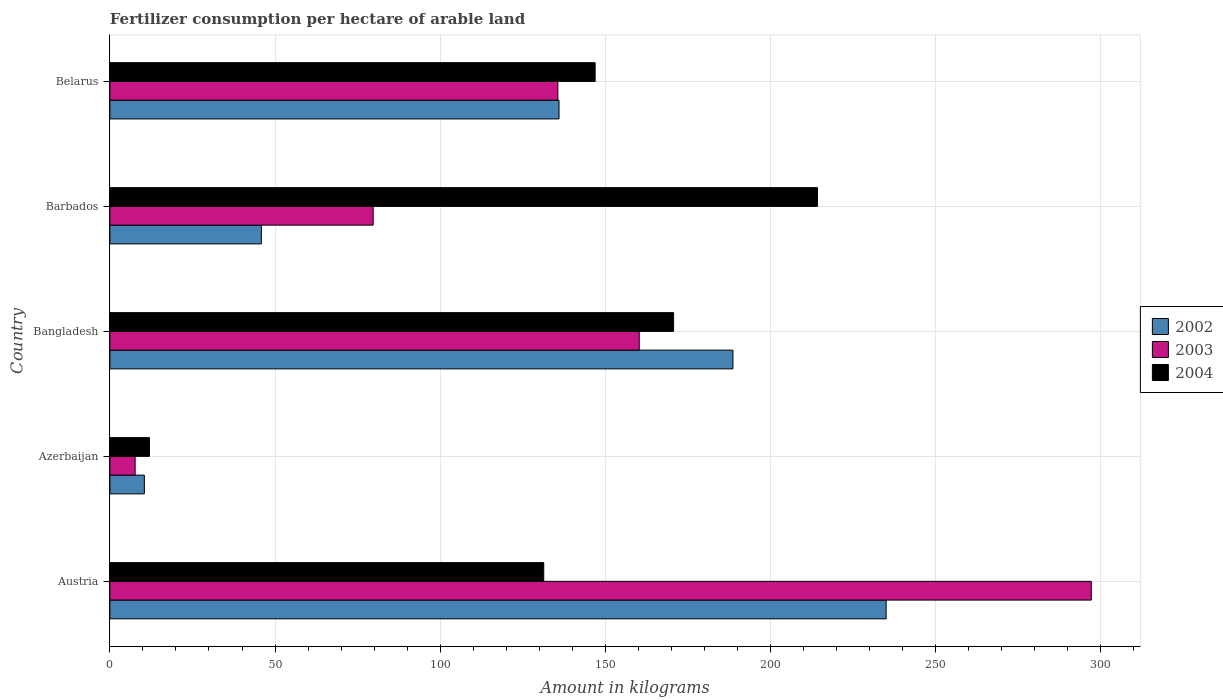How many different coloured bars are there?
Give a very brief answer. 3. Are the number of bars per tick equal to the number of legend labels?
Offer a very short reply. Yes. Are the number of bars on each tick of the Y-axis equal?
Provide a short and direct response. Yes. How many bars are there on the 3rd tick from the top?
Keep it short and to the point. 3. In how many cases, is the number of bars for a given country not equal to the number of legend labels?
Your answer should be very brief. 0. What is the amount of fertilizer consumption in 2002 in Austria?
Make the answer very short. 235.03. Across all countries, what is the maximum amount of fertilizer consumption in 2002?
Your response must be concise. 235.03. Across all countries, what is the minimum amount of fertilizer consumption in 2002?
Ensure brevity in your answer.  10.43. In which country was the amount of fertilizer consumption in 2004 maximum?
Offer a very short reply. Barbados. In which country was the amount of fertilizer consumption in 2002 minimum?
Your answer should be compact. Azerbaijan. What is the total amount of fertilizer consumption in 2003 in the graph?
Give a very brief answer. 680.39. What is the difference between the amount of fertilizer consumption in 2004 in Austria and that in Belarus?
Your response must be concise. -15.57. What is the difference between the amount of fertilizer consumption in 2003 in Barbados and the amount of fertilizer consumption in 2004 in Belarus?
Your answer should be compact. -67.2. What is the average amount of fertilizer consumption in 2003 per country?
Your response must be concise. 136.08. What is the difference between the amount of fertilizer consumption in 2003 and amount of fertilizer consumption in 2004 in Bangladesh?
Keep it short and to the point. -10.4. In how many countries, is the amount of fertilizer consumption in 2004 greater than 40 kg?
Make the answer very short. 4. What is the ratio of the amount of fertilizer consumption in 2002 in Azerbaijan to that in Belarus?
Your answer should be very brief. 0.08. Is the amount of fertilizer consumption in 2003 in Bangladesh less than that in Belarus?
Your answer should be compact. No. What is the difference between the highest and the second highest amount of fertilizer consumption in 2004?
Offer a very short reply. 43.56. What is the difference between the highest and the lowest amount of fertilizer consumption in 2004?
Ensure brevity in your answer.  202.26. In how many countries, is the amount of fertilizer consumption in 2003 greater than the average amount of fertilizer consumption in 2003 taken over all countries?
Provide a short and direct response. 2. Is the sum of the amount of fertilizer consumption in 2004 in Bangladesh and Barbados greater than the maximum amount of fertilizer consumption in 2003 across all countries?
Your answer should be compact. Yes. What does the 2nd bar from the top in Bangladesh represents?
Give a very brief answer. 2003. What does the 2nd bar from the bottom in Bangladesh represents?
Offer a very short reply. 2003. Is it the case that in every country, the sum of the amount of fertilizer consumption in 2002 and amount of fertilizer consumption in 2003 is greater than the amount of fertilizer consumption in 2004?
Your answer should be compact. No. What is the difference between two consecutive major ticks on the X-axis?
Give a very brief answer. 50. Are the values on the major ticks of X-axis written in scientific E-notation?
Provide a short and direct response. No. Does the graph contain grids?
Your answer should be very brief. Yes. Where does the legend appear in the graph?
Offer a terse response. Center right. How many legend labels are there?
Provide a short and direct response. 3. How are the legend labels stacked?
Give a very brief answer. Vertical. What is the title of the graph?
Provide a succinct answer. Fertilizer consumption per hectare of arable land. Does "1993" appear as one of the legend labels in the graph?
Your response must be concise. No. What is the label or title of the X-axis?
Keep it short and to the point. Amount in kilograms. What is the Amount in kilograms in 2002 in Austria?
Make the answer very short. 235.03. What is the Amount in kilograms of 2003 in Austria?
Provide a succinct answer. 297.14. What is the Amount in kilograms of 2004 in Austria?
Your answer should be very brief. 131.35. What is the Amount in kilograms in 2002 in Azerbaijan?
Provide a succinct answer. 10.43. What is the Amount in kilograms of 2003 in Azerbaijan?
Give a very brief answer. 7.64. What is the Amount in kilograms of 2004 in Azerbaijan?
Keep it short and to the point. 11.97. What is the Amount in kilograms of 2002 in Bangladesh?
Your response must be concise. 188.64. What is the Amount in kilograms in 2003 in Bangladesh?
Offer a terse response. 160.27. What is the Amount in kilograms in 2004 in Bangladesh?
Give a very brief answer. 170.67. What is the Amount in kilograms of 2002 in Barbados?
Your response must be concise. 45.86. What is the Amount in kilograms in 2003 in Barbados?
Provide a succinct answer. 79.71. What is the Amount in kilograms of 2004 in Barbados?
Your answer should be compact. 214.23. What is the Amount in kilograms of 2002 in Belarus?
Your answer should be compact. 135.99. What is the Amount in kilograms in 2003 in Belarus?
Your response must be concise. 135.63. What is the Amount in kilograms in 2004 in Belarus?
Offer a very short reply. 146.92. Across all countries, what is the maximum Amount in kilograms in 2002?
Your response must be concise. 235.03. Across all countries, what is the maximum Amount in kilograms in 2003?
Your answer should be compact. 297.14. Across all countries, what is the maximum Amount in kilograms of 2004?
Provide a succinct answer. 214.23. Across all countries, what is the minimum Amount in kilograms of 2002?
Provide a short and direct response. 10.43. Across all countries, what is the minimum Amount in kilograms of 2003?
Your answer should be compact. 7.64. Across all countries, what is the minimum Amount in kilograms in 2004?
Give a very brief answer. 11.97. What is the total Amount in kilograms of 2002 in the graph?
Offer a terse response. 615.94. What is the total Amount in kilograms of 2003 in the graph?
Your response must be concise. 680.39. What is the total Amount in kilograms of 2004 in the graph?
Provide a short and direct response. 675.15. What is the difference between the Amount in kilograms of 2002 in Austria and that in Azerbaijan?
Ensure brevity in your answer.  224.59. What is the difference between the Amount in kilograms in 2003 in Austria and that in Azerbaijan?
Give a very brief answer. 289.5. What is the difference between the Amount in kilograms in 2004 in Austria and that in Azerbaijan?
Provide a succinct answer. 119.38. What is the difference between the Amount in kilograms of 2002 in Austria and that in Bangladesh?
Make the answer very short. 46.39. What is the difference between the Amount in kilograms in 2003 in Austria and that in Bangladesh?
Make the answer very short. 136.87. What is the difference between the Amount in kilograms of 2004 in Austria and that in Bangladesh?
Your answer should be compact. -39.32. What is the difference between the Amount in kilograms of 2002 in Austria and that in Barbados?
Provide a short and direct response. 189.17. What is the difference between the Amount in kilograms in 2003 in Austria and that in Barbados?
Your answer should be compact. 217.42. What is the difference between the Amount in kilograms in 2004 in Austria and that in Barbados?
Your answer should be very brief. -82.88. What is the difference between the Amount in kilograms in 2002 in Austria and that in Belarus?
Your answer should be compact. 99.04. What is the difference between the Amount in kilograms in 2003 in Austria and that in Belarus?
Your response must be concise. 161.51. What is the difference between the Amount in kilograms of 2004 in Austria and that in Belarus?
Provide a succinct answer. -15.57. What is the difference between the Amount in kilograms of 2002 in Azerbaijan and that in Bangladesh?
Your response must be concise. -178.21. What is the difference between the Amount in kilograms of 2003 in Azerbaijan and that in Bangladesh?
Your response must be concise. -152.62. What is the difference between the Amount in kilograms in 2004 in Azerbaijan and that in Bangladesh?
Your response must be concise. -158.7. What is the difference between the Amount in kilograms in 2002 in Azerbaijan and that in Barbados?
Your response must be concise. -35.42. What is the difference between the Amount in kilograms in 2003 in Azerbaijan and that in Barbados?
Keep it short and to the point. -72.07. What is the difference between the Amount in kilograms in 2004 in Azerbaijan and that in Barbados?
Your answer should be compact. -202.26. What is the difference between the Amount in kilograms in 2002 in Azerbaijan and that in Belarus?
Your answer should be very brief. -125.55. What is the difference between the Amount in kilograms of 2003 in Azerbaijan and that in Belarus?
Your answer should be very brief. -127.98. What is the difference between the Amount in kilograms in 2004 in Azerbaijan and that in Belarus?
Offer a very short reply. -134.94. What is the difference between the Amount in kilograms of 2002 in Bangladesh and that in Barbados?
Offer a terse response. 142.78. What is the difference between the Amount in kilograms in 2003 in Bangladesh and that in Barbados?
Offer a terse response. 80.55. What is the difference between the Amount in kilograms in 2004 in Bangladesh and that in Barbados?
Give a very brief answer. -43.56. What is the difference between the Amount in kilograms in 2002 in Bangladesh and that in Belarus?
Your answer should be very brief. 52.65. What is the difference between the Amount in kilograms of 2003 in Bangladesh and that in Belarus?
Your response must be concise. 24.64. What is the difference between the Amount in kilograms in 2004 in Bangladesh and that in Belarus?
Your answer should be very brief. 23.75. What is the difference between the Amount in kilograms in 2002 in Barbados and that in Belarus?
Provide a succinct answer. -90.13. What is the difference between the Amount in kilograms in 2003 in Barbados and that in Belarus?
Give a very brief answer. -55.91. What is the difference between the Amount in kilograms of 2004 in Barbados and that in Belarus?
Provide a short and direct response. 67.31. What is the difference between the Amount in kilograms in 2002 in Austria and the Amount in kilograms in 2003 in Azerbaijan?
Your answer should be compact. 227.38. What is the difference between the Amount in kilograms of 2002 in Austria and the Amount in kilograms of 2004 in Azerbaijan?
Your response must be concise. 223.05. What is the difference between the Amount in kilograms of 2003 in Austria and the Amount in kilograms of 2004 in Azerbaijan?
Offer a very short reply. 285.16. What is the difference between the Amount in kilograms in 2002 in Austria and the Amount in kilograms in 2003 in Bangladesh?
Keep it short and to the point. 74.76. What is the difference between the Amount in kilograms in 2002 in Austria and the Amount in kilograms in 2004 in Bangladesh?
Your response must be concise. 64.35. What is the difference between the Amount in kilograms in 2003 in Austria and the Amount in kilograms in 2004 in Bangladesh?
Provide a succinct answer. 126.47. What is the difference between the Amount in kilograms in 2002 in Austria and the Amount in kilograms in 2003 in Barbados?
Your answer should be compact. 155.31. What is the difference between the Amount in kilograms of 2002 in Austria and the Amount in kilograms of 2004 in Barbados?
Your answer should be compact. 20.79. What is the difference between the Amount in kilograms of 2003 in Austria and the Amount in kilograms of 2004 in Barbados?
Ensure brevity in your answer.  82.91. What is the difference between the Amount in kilograms of 2002 in Austria and the Amount in kilograms of 2003 in Belarus?
Provide a succinct answer. 99.4. What is the difference between the Amount in kilograms in 2002 in Austria and the Amount in kilograms in 2004 in Belarus?
Provide a short and direct response. 88.11. What is the difference between the Amount in kilograms in 2003 in Austria and the Amount in kilograms in 2004 in Belarus?
Provide a short and direct response. 150.22. What is the difference between the Amount in kilograms of 2002 in Azerbaijan and the Amount in kilograms of 2003 in Bangladesh?
Give a very brief answer. -149.83. What is the difference between the Amount in kilograms in 2002 in Azerbaijan and the Amount in kilograms in 2004 in Bangladesh?
Ensure brevity in your answer.  -160.24. What is the difference between the Amount in kilograms in 2003 in Azerbaijan and the Amount in kilograms in 2004 in Bangladesh?
Keep it short and to the point. -163.03. What is the difference between the Amount in kilograms of 2002 in Azerbaijan and the Amount in kilograms of 2003 in Barbados?
Provide a succinct answer. -69.28. What is the difference between the Amount in kilograms in 2002 in Azerbaijan and the Amount in kilograms in 2004 in Barbados?
Your answer should be compact. -203.8. What is the difference between the Amount in kilograms in 2003 in Azerbaijan and the Amount in kilograms in 2004 in Barbados?
Ensure brevity in your answer.  -206.59. What is the difference between the Amount in kilograms in 2002 in Azerbaijan and the Amount in kilograms in 2003 in Belarus?
Provide a succinct answer. -125.19. What is the difference between the Amount in kilograms of 2002 in Azerbaijan and the Amount in kilograms of 2004 in Belarus?
Ensure brevity in your answer.  -136.48. What is the difference between the Amount in kilograms of 2003 in Azerbaijan and the Amount in kilograms of 2004 in Belarus?
Offer a very short reply. -139.28. What is the difference between the Amount in kilograms of 2002 in Bangladesh and the Amount in kilograms of 2003 in Barbados?
Make the answer very short. 108.92. What is the difference between the Amount in kilograms of 2002 in Bangladesh and the Amount in kilograms of 2004 in Barbados?
Keep it short and to the point. -25.59. What is the difference between the Amount in kilograms of 2003 in Bangladesh and the Amount in kilograms of 2004 in Barbados?
Provide a succinct answer. -53.96. What is the difference between the Amount in kilograms in 2002 in Bangladesh and the Amount in kilograms in 2003 in Belarus?
Provide a succinct answer. 53.01. What is the difference between the Amount in kilograms in 2002 in Bangladesh and the Amount in kilograms in 2004 in Belarus?
Offer a terse response. 41.72. What is the difference between the Amount in kilograms of 2003 in Bangladesh and the Amount in kilograms of 2004 in Belarus?
Keep it short and to the point. 13.35. What is the difference between the Amount in kilograms of 2002 in Barbados and the Amount in kilograms of 2003 in Belarus?
Your answer should be compact. -89.77. What is the difference between the Amount in kilograms in 2002 in Barbados and the Amount in kilograms in 2004 in Belarus?
Give a very brief answer. -101.06. What is the difference between the Amount in kilograms in 2003 in Barbados and the Amount in kilograms in 2004 in Belarus?
Ensure brevity in your answer.  -67.2. What is the average Amount in kilograms in 2002 per country?
Provide a succinct answer. 123.19. What is the average Amount in kilograms of 2003 per country?
Offer a terse response. 136.08. What is the average Amount in kilograms of 2004 per country?
Offer a very short reply. 135.03. What is the difference between the Amount in kilograms in 2002 and Amount in kilograms in 2003 in Austria?
Provide a succinct answer. -62.11. What is the difference between the Amount in kilograms of 2002 and Amount in kilograms of 2004 in Austria?
Give a very brief answer. 103.67. What is the difference between the Amount in kilograms of 2003 and Amount in kilograms of 2004 in Austria?
Make the answer very short. 165.79. What is the difference between the Amount in kilograms of 2002 and Amount in kilograms of 2003 in Azerbaijan?
Your answer should be compact. 2.79. What is the difference between the Amount in kilograms of 2002 and Amount in kilograms of 2004 in Azerbaijan?
Keep it short and to the point. -1.54. What is the difference between the Amount in kilograms of 2003 and Amount in kilograms of 2004 in Azerbaijan?
Provide a short and direct response. -4.33. What is the difference between the Amount in kilograms in 2002 and Amount in kilograms in 2003 in Bangladesh?
Provide a short and direct response. 28.37. What is the difference between the Amount in kilograms in 2002 and Amount in kilograms in 2004 in Bangladesh?
Offer a terse response. 17.97. What is the difference between the Amount in kilograms in 2003 and Amount in kilograms in 2004 in Bangladesh?
Your answer should be compact. -10.4. What is the difference between the Amount in kilograms of 2002 and Amount in kilograms of 2003 in Barbados?
Keep it short and to the point. -33.86. What is the difference between the Amount in kilograms of 2002 and Amount in kilograms of 2004 in Barbados?
Offer a very short reply. -168.37. What is the difference between the Amount in kilograms of 2003 and Amount in kilograms of 2004 in Barbados?
Offer a terse response. -134.52. What is the difference between the Amount in kilograms of 2002 and Amount in kilograms of 2003 in Belarus?
Give a very brief answer. 0.36. What is the difference between the Amount in kilograms in 2002 and Amount in kilograms in 2004 in Belarus?
Your answer should be compact. -10.93. What is the difference between the Amount in kilograms in 2003 and Amount in kilograms in 2004 in Belarus?
Give a very brief answer. -11.29. What is the ratio of the Amount in kilograms in 2002 in Austria to that in Azerbaijan?
Keep it short and to the point. 22.53. What is the ratio of the Amount in kilograms of 2003 in Austria to that in Azerbaijan?
Provide a short and direct response. 38.88. What is the ratio of the Amount in kilograms in 2004 in Austria to that in Azerbaijan?
Offer a very short reply. 10.97. What is the ratio of the Amount in kilograms in 2002 in Austria to that in Bangladesh?
Offer a very short reply. 1.25. What is the ratio of the Amount in kilograms in 2003 in Austria to that in Bangladesh?
Give a very brief answer. 1.85. What is the ratio of the Amount in kilograms in 2004 in Austria to that in Bangladesh?
Your answer should be compact. 0.77. What is the ratio of the Amount in kilograms in 2002 in Austria to that in Barbados?
Offer a terse response. 5.13. What is the ratio of the Amount in kilograms in 2003 in Austria to that in Barbados?
Provide a succinct answer. 3.73. What is the ratio of the Amount in kilograms in 2004 in Austria to that in Barbados?
Your response must be concise. 0.61. What is the ratio of the Amount in kilograms of 2002 in Austria to that in Belarus?
Give a very brief answer. 1.73. What is the ratio of the Amount in kilograms of 2003 in Austria to that in Belarus?
Your answer should be very brief. 2.19. What is the ratio of the Amount in kilograms of 2004 in Austria to that in Belarus?
Offer a terse response. 0.89. What is the ratio of the Amount in kilograms in 2002 in Azerbaijan to that in Bangladesh?
Ensure brevity in your answer.  0.06. What is the ratio of the Amount in kilograms in 2003 in Azerbaijan to that in Bangladesh?
Offer a terse response. 0.05. What is the ratio of the Amount in kilograms of 2004 in Azerbaijan to that in Bangladesh?
Give a very brief answer. 0.07. What is the ratio of the Amount in kilograms of 2002 in Azerbaijan to that in Barbados?
Give a very brief answer. 0.23. What is the ratio of the Amount in kilograms of 2003 in Azerbaijan to that in Barbados?
Offer a very short reply. 0.1. What is the ratio of the Amount in kilograms in 2004 in Azerbaijan to that in Barbados?
Offer a very short reply. 0.06. What is the ratio of the Amount in kilograms of 2002 in Azerbaijan to that in Belarus?
Your response must be concise. 0.08. What is the ratio of the Amount in kilograms of 2003 in Azerbaijan to that in Belarus?
Offer a terse response. 0.06. What is the ratio of the Amount in kilograms of 2004 in Azerbaijan to that in Belarus?
Offer a very short reply. 0.08. What is the ratio of the Amount in kilograms of 2002 in Bangladesh to that in Barbados?
Ensure brevity in your answer.  4.11. What is the ratio of the Amount in kilograms in 2003 in Bangladesh to that in Barbados?
Your answer should be compact. 2.01. What is the ratio of the Amount in kilograms in 2004 in Bangladesh to that in Barbados?
Make the answer very short. 0.8. What is the ratio of the Amount in kilograms of 2002 in Bangladesh to that in Belarus?
Offer a very short reply. 1.39. What is the ratio of the Amount in kilograms of 2003 in Bangladesh to that in Belarus?
Keep it short and to the point. 1.18. What is the ratio of the Amount in kilograms of 2004 in Bangladesh to that in Belarus?
Your answer should be very brief. 1.16. What is the ratio of the Amount in kilograms of 2002 in Barbados to that in Belarus?
Provide a short and direct response. 0.34. What is the ratio of the Amount in kilograms of 2003 in Barbados to that in Belarus?
Offer a very short reply. 0.59. What is the ratio of the Amount in kilograms of 2004 in Barbados to that in Belarus?
Ensure brevity in your answer.  1.46. What is the difference between the highest and the second highest Amount in kilograms of 2002?
Give a very brief answer. 46.39. What is the difference between the highest and the second highest Amount in kilograms of 2003?
Ensure brevity in your answer.  136.87. What is the difference between the highest and the second highest Amount in kilograms of 2004?
Provide a succinct answer. 43.56. What is the difference between the highest and the lowest Amount in kilograms of 2002?
Your answer should be compact. 224.59. What is the difference between the highest and the lowest Amount in kilograms of 2003?
Offer a terse response. 289.5. What is the difference between the highest and the lowest Amount in kilograms in 2004?
Provide a succinct answer. 202.26. 